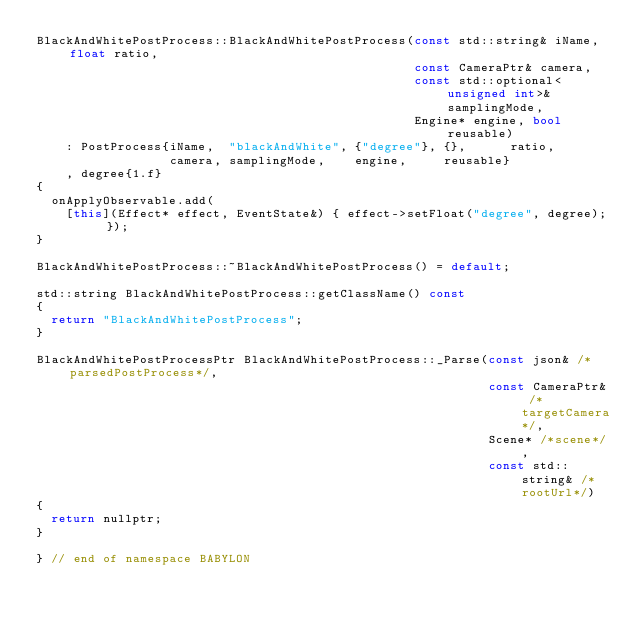<code> <loc_0><loc_0><loc_500><loc_500><_C++_>BlackAndWhitePostProcess::BlackAndWhitePostProcess(const std::string& iName, float ratio,
                                                   const CameraPtr& camera,
                                                   const std::optional<unsigned int>& samplingMode,
                                                   Engine* engine, bool reusable)
    : PostProcess{iName,  "blackAndWhite", {"degree"}, {},      ratio,
                  camera, samplingMode,    engine,     reusable}
    , degree{1.f}
{
  onApplyObservable.add(
    [this](Effect* effect, EventState&) { effect->setFloat("degree", degree); });
}

BlackAndWhitePostProcess::~BlackAndWhitePostProcess() = default;

std::string BlackAndWhitePostProcess::getClassName() const
{
  return "BlackAndWhitePostProcess";
}

BlackAndWhitePostProcessPtr BlackAndWhitePostProcess::_Parse(const json& /*parsedPostProcess*/,
                                                             const CameraPtr& /*targetCamera*/,
                                                             Scene* /*scene*/,
                                                             const std::string& /*rootUrl*/)
{
  return nullptr;
}

} // end of namespace BABYLON
</code> 